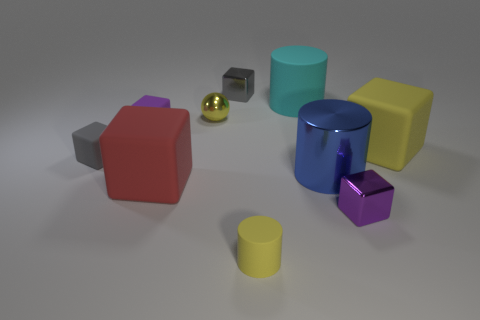Subtract all big red rubber cubes. How many cubes are left? 5 Subtract all yellow cylinders. How many purple cubes are left? 2 Subtract all red cubes. How many cubes are left? 5 Subtract all blocks. How many objects are left? 4 Subtract 1 spheres. How many spheres are left? 0 Subtract all gray blocks. Subtract all gray spheres. How many blocks are left? 4 Subtract all small cyan objects. Subtract all tiny purple shiny cubes. How many objects are left? 9 Add 4 small purple matte cubes. How many small purple matte cubes are left? 5 Add 8 small gray rubber blocks. How many small gray rubber blocks exist? 9 Subtract 0 purple cylinders. How many objects are left? 10 